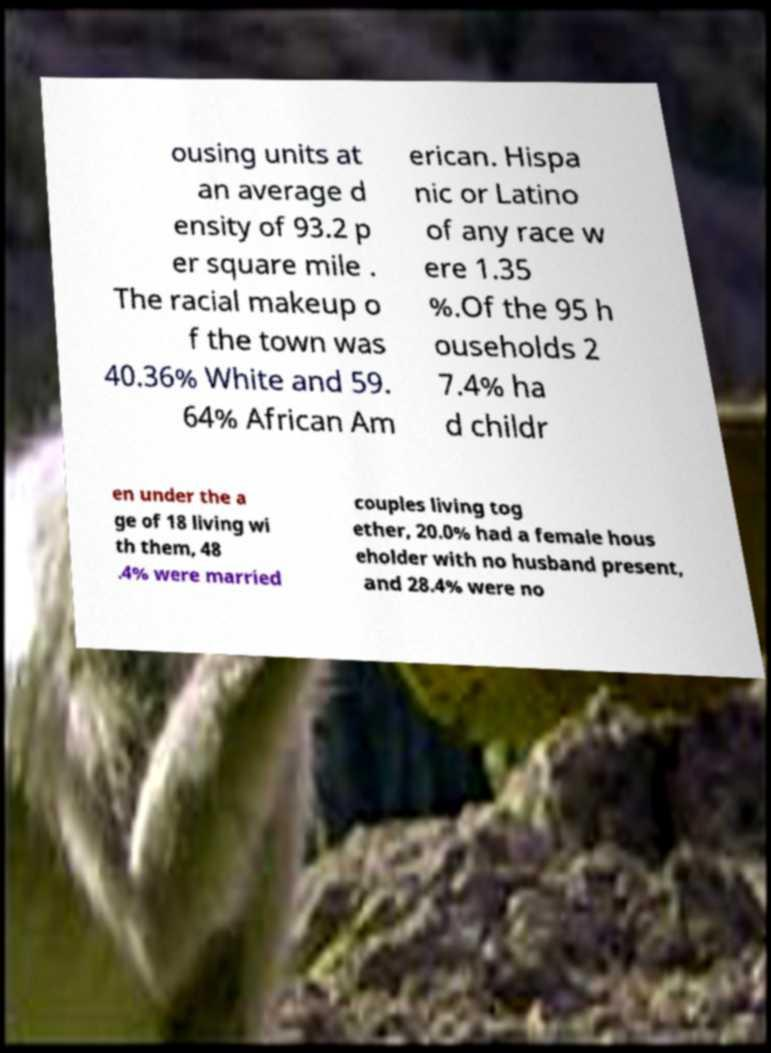Please read and relay the text visible in this image. What does it say? ousing units at an average d ensity of 93.2 p er square mile . The racial makeup o f the town was 40.36% White and 59. 64% African Am erican. Hispa nic or Latino of any race w ere 1.35 %.Of the 95 h ouseholds 2 7.4% ha d childr en under the a ge of 18 living wi th them, 48 .4% were married couples living tog ether, 20.0% had a female hous eholder with no husband present, and 28.4% were no 